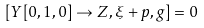<formula> <loc_0><loc_0><loc_500><loc_500>[ Y [ 0 , 1 , 0 ] \to Z , \xi + p , g ] = 0</formula> 